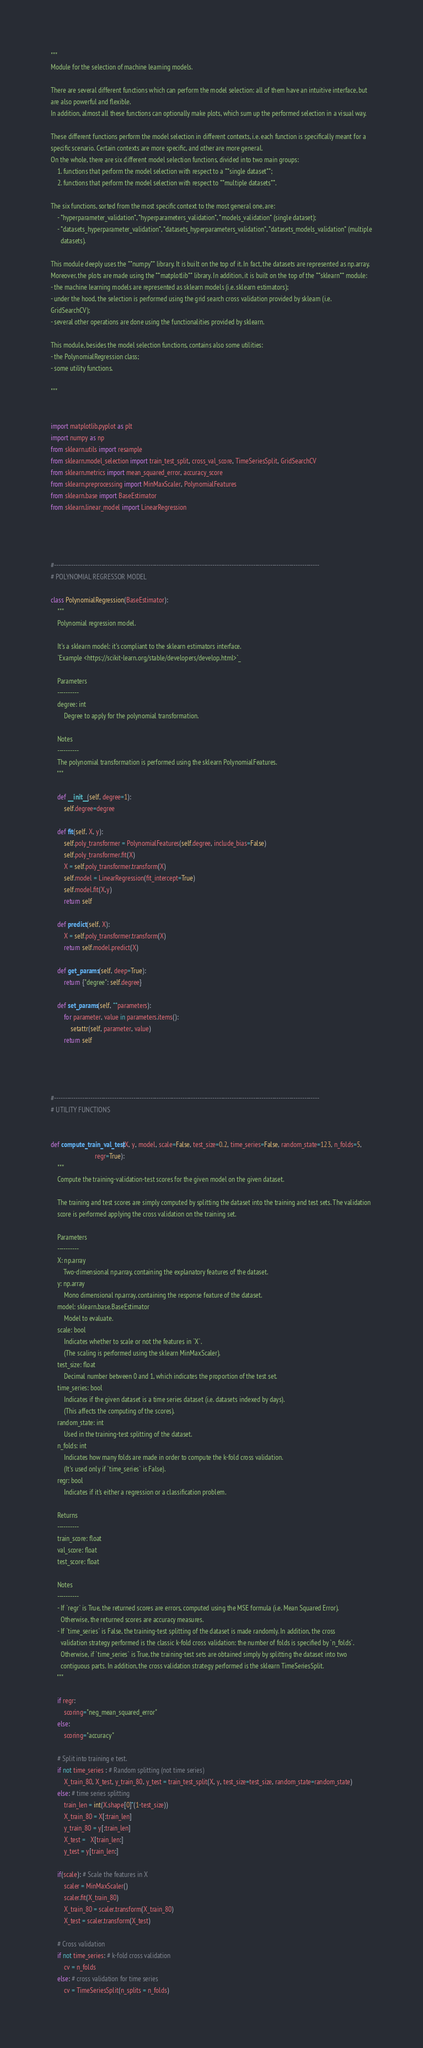<code> <loc_0><loc_0><loc_500><loc_500><_Python_>"""
Module for the selection of machine learning models.

There are several different functions which can perform the model selection: all of them have an intuitive interface, but
are also powerful and flexible.
In addition, almost all these functions can optionally make plots, which sum up the performed selection in a visual way.

These different functions perform the model selection in different contexts, i.e. each function is specifically meant for a
specific scenario. Certain contexts are more specific, and other are more general.
On the whole, there are six different model selection functions, divided into two main groups:
    1. functions that perform the model selection with respect to a **single dataset**;
    2. functions that perform the model selection with respect to **multiple datasets**.

The six functions, sorted from the most specific context to the most general one, are:
    - *hyperparameter_validation*, *hyperparameters_validation*, *models_validation* (single dataset);
    - *datasets_hyperparameter_validation*, *datasets_hyperparameters_validation*, *datasets_models_validation* (multiple
      datasets).

This module deeply uses the **numpy** library. It is built on the top of it. In fact, the datasets are represented as np.array.
Moreover, the plots are made using the **matplotlib** library. In addition, it is built on the top of the **sklearn** module:
- the machine learning models are represented as sklearn models (i.e. sklearn estimators);
- under the hood, the selection is performed using the grid search cross validation provided by sklearn (i.e.
GridSearchCV);
- several other operations are done using the functionalities provided by sklearn.

This module, besides the model selection functions, contains also some utilities:
- the PolynomialRegression class;
- some utility functions.

"""


import matplotlib.pyplot as plt
import numpy as np
from sklearn.utils import resample
from sklearn.model_selection import train_test_split, cross_val_score, TimeSeriesSplit, GridSearchCV
from sklearn.metrics import mean_squared_error, accuracy_score
from sklearn.preprocessing import MinMaxScaler, PolynomialFeatures
from sklearn.base import BaseEstimator
from sklearn.linear_model import LinearRegression




#----------------------------------------------------------------------------------------------------------------------------
# POLYNOMIAL REGRESSOR MODEL

class PolynomialRegression(BaseEstimator):
    """
    Polynomial regression model.

    It's a sklearn model: it's compliant to the sklearn estimators interface.
    `Example <https://scikit-learn.org/stable/developers/develop.html>`_

    Parameters
    ----------
    degree: int
        Degree to apply for the polynomial transformation.

    Notes
    ----------
    The polynomial transformation is performed using the sklearn PolynomialFeatures.
    """

    def __init__(self, degree=1):
        self.degree=degree

    def fit(self, X, y):
        self.poly_transformer = PolynomialFeatures(self.degree, include_bias=False)
        self.poly_transformer.fit(X)
        X = self.poly_transformer.transform(X)
        self.model = LinearRegression(fit_intercept=True)
        self.model.fit(X,y)
        return self

    def predict(self, X):
        X = self.poly_transformer.transform(X)
        return self.model.predict(X)

    def get_params(self, deep=True):
        return {"degree": self.degree}

    def set_params(self, **parameters):
        for parameter, value in parameters.items():
            setattr(self, parameter, value)
        return self




#----------------------------------------------------------------------------------------------------------------------------
# UTILITY FUNCTIONS


def compute_train_val_test(X, y, model, scale=False, test_size=0.2, time_series=False, random_state=123, n_folds=5,
                           regr=True):
    """
    Compute the training-validation-test scores for the given model on the given dataset.

    The training and test scores are simply computed by splitting the dataset into the training and test sets. The validation
    score is performed applying the cross validation on the training set.

    Parameters
    ----------
    X: np.array
        Two-dimensional np.array, containing the explanatory features of the dataset.
    y: np.array
        Mono dimensional np.array, containing the response feature of the dataset.
    model: sklearn.base.BaseEstimator
        Model to evaluate.
    scale: bool
        Indicates whether to scale or not the features in `X`.
        (The scaling is performed using the sklearn MinMaxScaler).
    test_size: float
        Decimal number between 0 and 1, which indicates the proportion of the test set.
    time_series: bool
        Indicates if the given dataset is a time series dataset (i.e. datasets indexed by days).
        (This affects the computing of the scores).
    random_state: int
        Used in the training-test splitting of the dataset.
    n_folds: int
        Indicates how many folds are made in order to compute the k-fold cross validation.
        (It's used only if `time_series` is False).
    regr: bool
        Indicates if it's either a regression or a classification problem.

    Returns
    ----------
    train_score: float
    val_score: float
    test_score: float

    Notes
    ----------
    - If `regr` is True, the returned scores are errors, computed using the MSE formula (i.e. Mean Squared Error).
      Otherwise, the returned scores are accuracy measures.
    - If `time_series` is False, the training-test splitting of the dataset is made randomly. In addition, the cross
      validation strategy performed is the classic k-fold cross validation: the number of folds is specified by `n_folds`.
      Otherwise, if `time_series` is True, the training-test sets are obtained simply by splitting the dataset into two
      contiguous parts. In addition, the cross validation strategy performed is the sklearn TimeSeriesSplit.
    """

    if regr:
        scoring="neg_mean_squared_error"
    else:
        scoring="accuracy"

    # Split into training e test.
    if not time_series : # Random splitting (not time series)
        X_train_80, X_test, y_train_80, y_test = train_test_split(X, y, test_size=test_size, random_state=random_state)
    else: # time series splitting
        train_len = int(X.shape[0]*(1-test_size))
        X_train_80 = X[:train_len]
        y_train_80 = y[:train_len]
        X_test =   X[train_len:]
        y_test = y[train_len:]

    if(scale): # Scale the features in X
        scaler = MinMaxScaler()
        scaler.fit(X_train_80)
        X_train_80 = scaler.transform(X_train_80)
        X_test = scaler.transform(X_test)

    # Cross validation
    if not time_series: # k-fold cross validation
        cv = n_folds
    else: # cross validation for time series
        cv = TimeSeriesSplit(n_splits = n_folds)</code> 